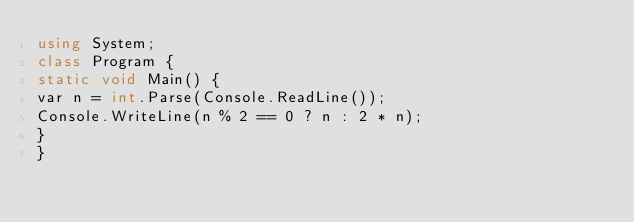Convert code to text. <code><loc_0><loc_0><loc_500><loc_500><_C#_>using System;
class Program {
static void Main() {
var n = int.Parse(Console.ReadLine());
Console.WriteLine(n % 2 == 0 ? n : 2 * n);
}
}
</code> 